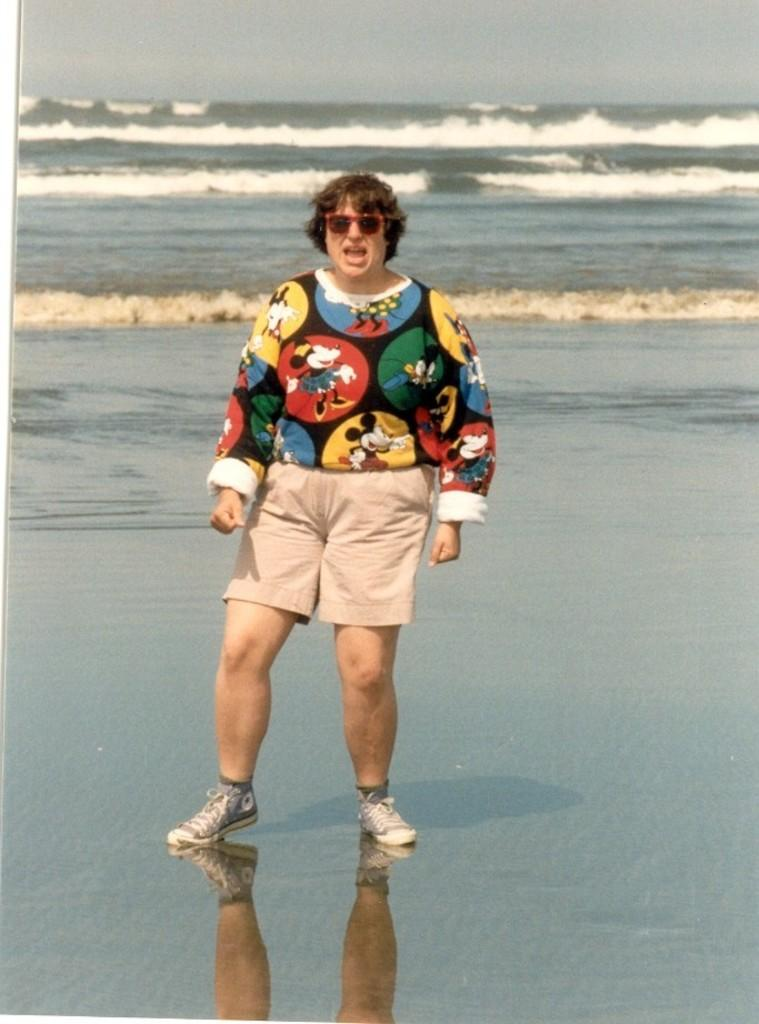What is the person in the image doing? The person is standing in the water. What can be observed about the water in the image? Waves are visible in the water. What year does the person experience the most pleasure while standing in the water? The image does not provide any information about the year or the person's level of pleasure, so it cannot be determined from the image. 